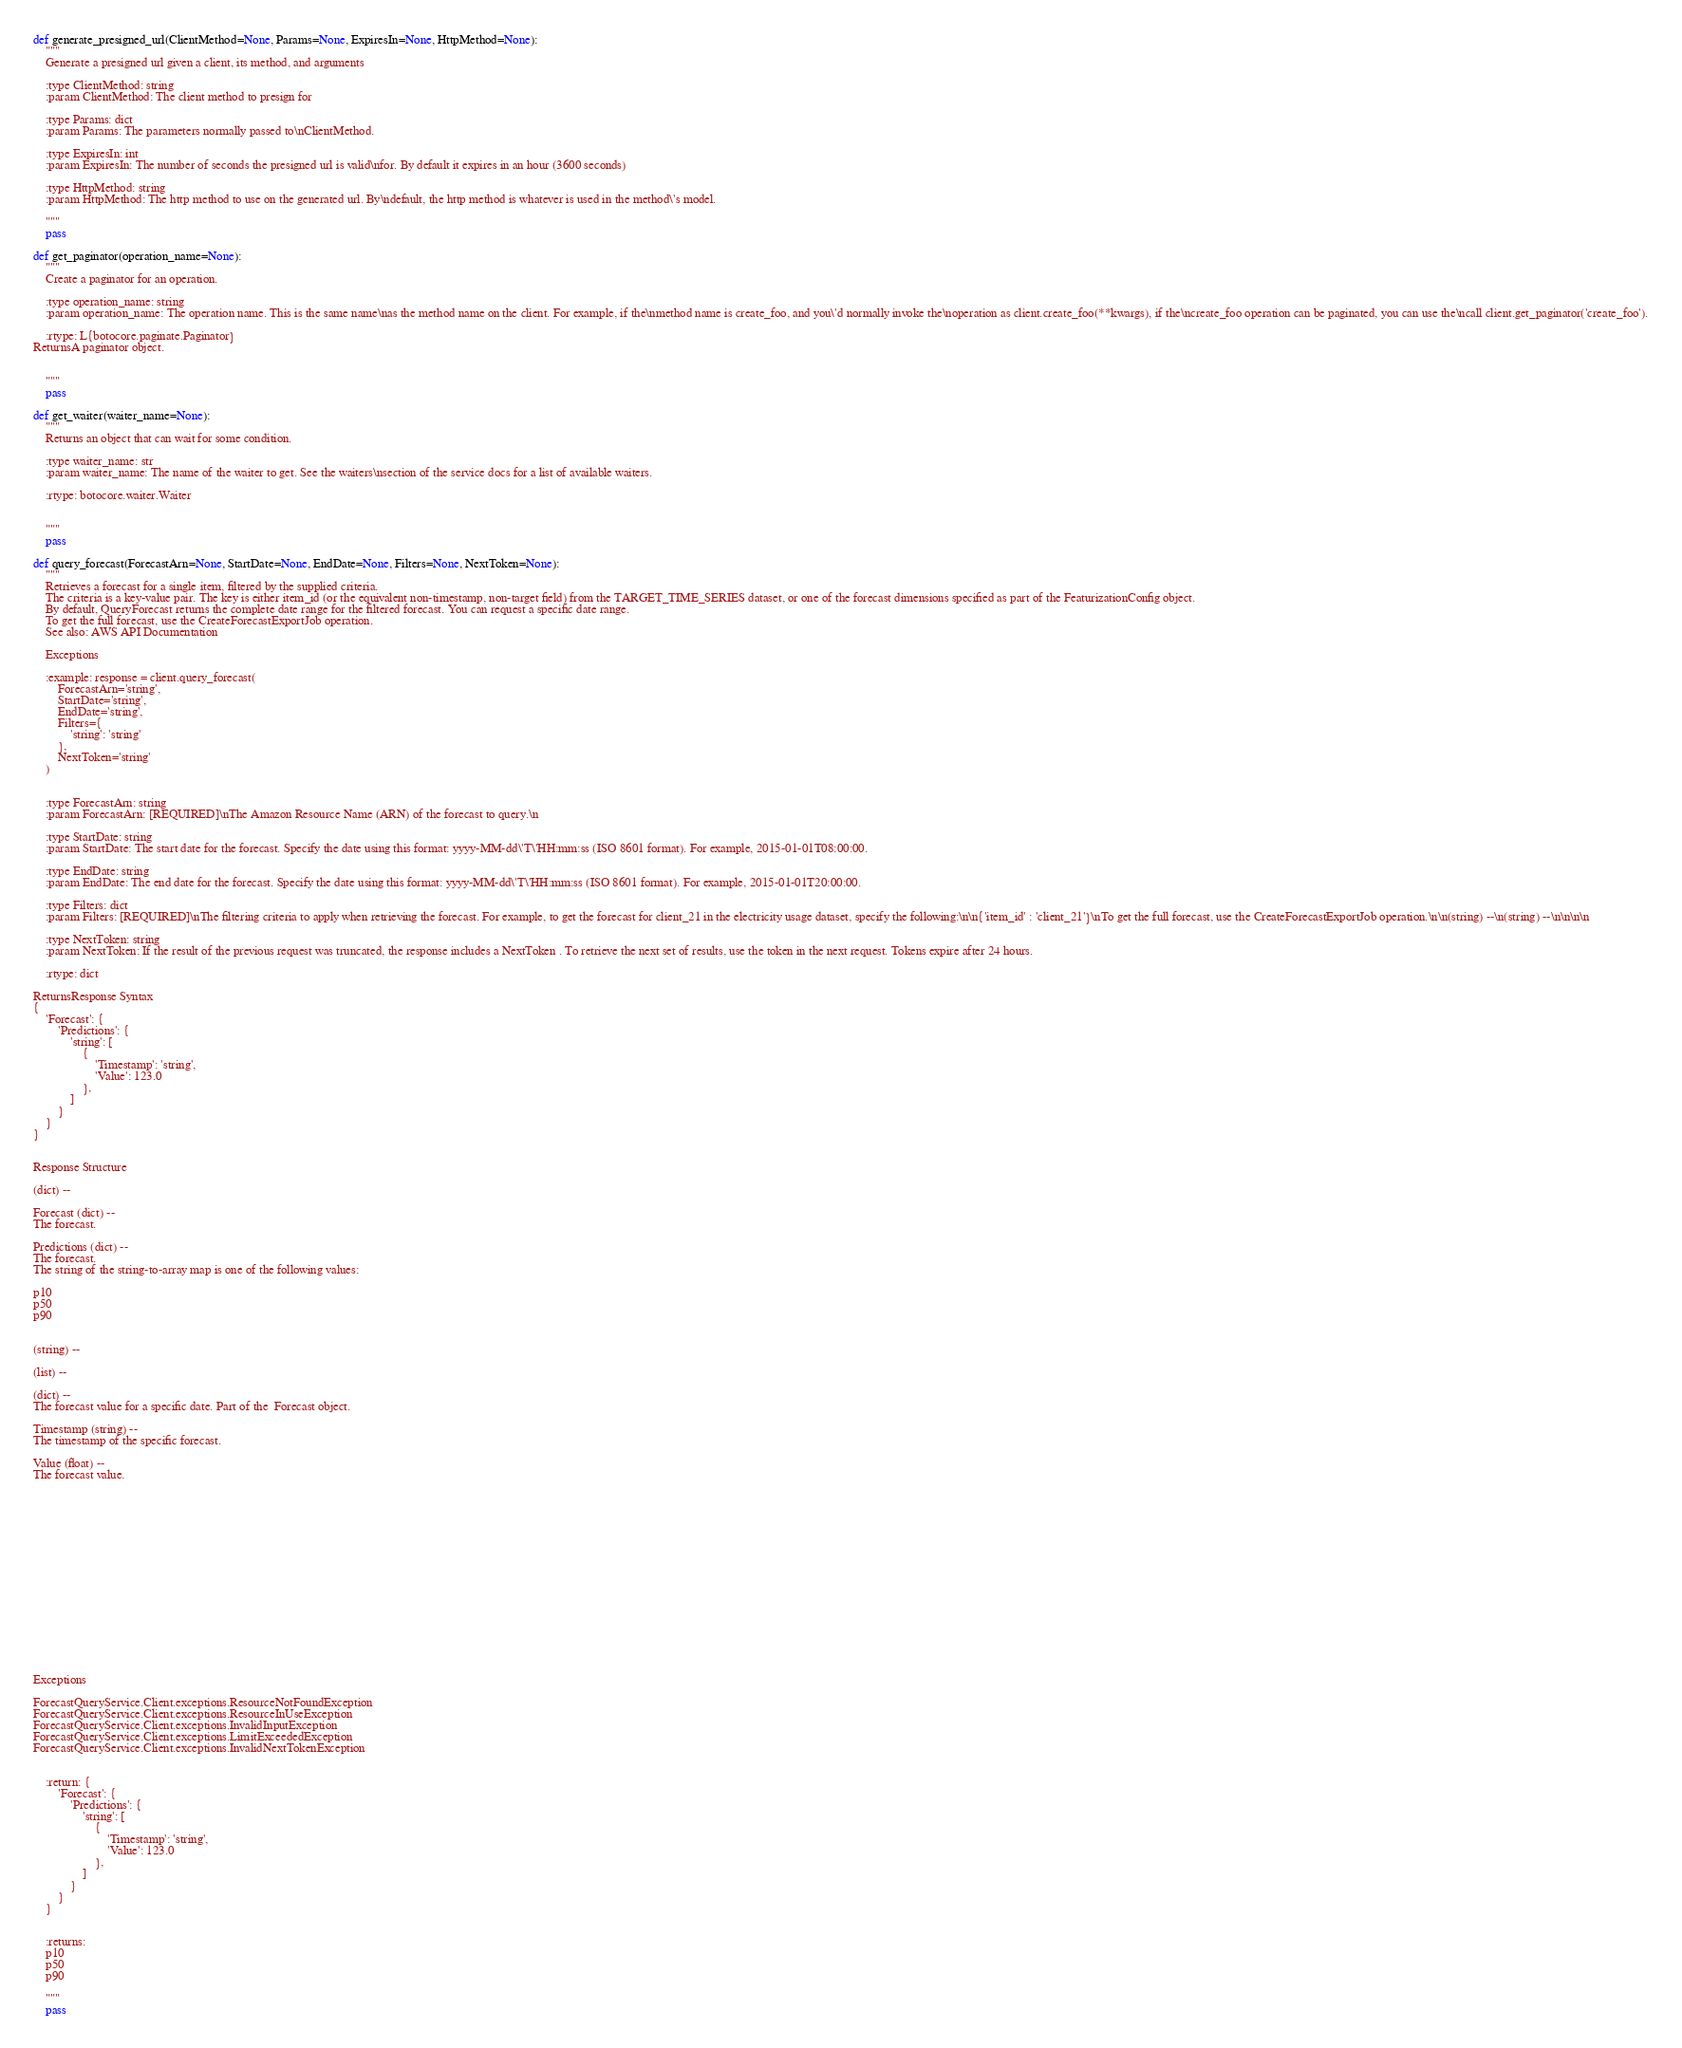Convert code to text. <code><loc_0><loc_0><loc_500><loc_500><_Python_>def generate_presigned_url(ClientMethod=None, Params=None, ExpiresIn=None, HttpMethod=None):
    """
    Generate a presigned url given a client, its method, and arguments
    
    :type ClientMethod: string
    :param ClientMethod: The client method to presign for

    :type Params: dict
    :param Params: The parameters normally passed to\nClientMethod.

    :type ExpiresIn: int
    :param ExpiresIn: The number of seconds the presigned url is valid\nfor. By default it expires in an hour (3600 seconds)

    :type HttpMethod: string
    :param HttpMethod: The http method to use on the generated url. By\ndefault, the http method is whatever is used in the method\'s model.

    """
    pass

def get_paginator(operation_name=None):
    """
    Create a paginator for an operation.
    
    :type operation_name: string
    :param operation_name: The operation name. This is the same name\nas the method name on the client. For example, if the\nmethod name is create_foo, and you\'d normally invoke the\noperation as client.create_foo(**kwargs), if the\ncreate_foo operation can be paginated, you can use the\ncall client.get_paginator('create_foo').

    :rtype: L{botocore.paginate.Paginator}
ReturnsA paginator object.


    """
    pass

def get_waiter(waiter_name=None):
    """
    Returns an object that can wait for some condition.
    
    :type waiter_name: str
    :param waiter_name: The name of the waiter to get. See the waiters\nsection of the service docs for a list of available waiters.

    :rtype: botocore.waiter.Waiter


    """
    pass

def query_forecast(ForecastArn=None, StartDate=None, EndDate=None, Filters=None, NextToken=None):
    """
    Retrieves a forecast for a single item, filtered by the supplied criteria.
    The criteria is a key-value pair. The key is either item_id (or the equivalent non-timestamp, non-target field) from the TARGET_TIME_SERIES dataset, or one of the forecast dimensions specified as part of the FeaturizationConfig object.
    By default, QueryForecast returns the complete date range for the filtered forecast. You can request a specific date range.
    To get the full forecast, use the CreateForecastExportJob operation.
    See also: AWS API Documentation
    
    Exceptions
    
    :example: response = client.query_forecast(
        ForecastArn='string',
        StartDate='string',
        EndDate='string',
        Filters={
            'string': 'string'
        },
        NextToken='string'
    )
    
    
    :type ForecastArn: string
    :param ForecastArn: [REQUIRED]\nThe Amazon Resource Name (ARN) of the forecast to query.\n

    :type StartDate: string
    :param StartDate: The start date for the forecast. Specify the date using this format: yyyy-MM-dd\'T\'HH:mm:ss (ISO 8601 format). For example, 2015-01-01T08:00:00.

    :type EndDate: string
    :param EndDate: The end date for the forecast. Specify the date using this format: yyyy-MM-dd\'T\'HH:mm:ss (ISO 8601 format). For example, 2015-01-01T20:00:00.

    :type Filters: dict
    :param Filters: [REQUIRED]\nThe filtering criteria to apply when retrieving the forecast. For example, to get the forecast for client_21 in the electricity usage dataset, specify the following:\n\n{'item_id' : 'client_21'}\nTo get the full forecast, use the CreateForecastExportJob operation.\n\n(string) --\n(string) --\n\n\n\n

    :type NextToken: string
    :param NextToken: If the result of the previous request was truncated, the response includes a NextToken . To retrieve the next set of results, use the token in the next request. Tokens expire after 24 hours.

    :rtype: dict

ReturnsResponse Syntax
{
    'Forecast': {
        'Predictions': {
            'string': [
                {
                    'Timestamp': 'string',
                    'Value': 123.0
                },
            ]
        }
    }
}


Response Structure

(dict) --

Forecast (dict) --
The forecast.

Predictions (dict) --
The forecast.
The string of the string-to-array map is one of the following values:

p10
p50
p90


(string) --

(list) --

(dict) --
The forecast value for a specific date. Part of the  Forecast object.

Timestamp (string) --
The timestamp of the specific forecast.

Value (float) --
The forecast value.

















Exceptions

ForecastQueryService.Client.exceptions.ResourceNotFoundException
ForecastQueryService.Client.exceptions.ResourceInUseException
ForecastQueryService.Client.exceptions.InvalidInputException
ForecastQueryService.Client.exceptions.LimitExceededException
ForecastQueryService.Client.exceptions.InvalidNextTokenException


    :return: {
        'Forecast': {
            'Predictions': {
                'string': [
                    {
                        'Timestamp': 'string',
                        'Value': 123.0
                    },
                ]
            }
        }
    }
    
    
    :returns: 
    p10
    p50
    p90
    
    """
    pass

</code> 